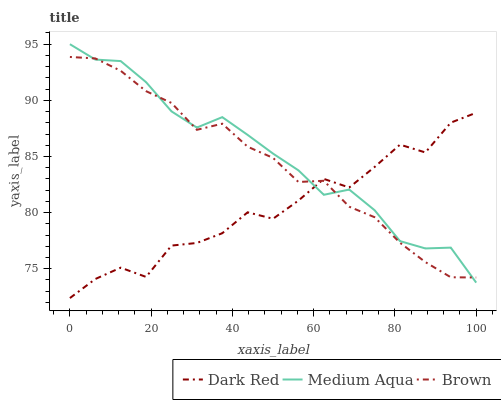Does Dark Red have the minimum area under the curve?
Answer yes or no. Yes. Does Medium Aqua have the maximum area under the curve?
Answer yes or no. Yes. Does Brown have the minimum area under the curve?
Answer yes or no. No. Does Brown have the maximum area under the curve?
Answer yes or no. No. Is Brown the smoothest?
Answer yes or no. Yes. Is Dark Red the roughest?
Answer yes or no. Yes. Is Medium Aqua the smoothest?
Answer yes or no. No. Is Medium Aqua the roughest?
Answer yes or no. No. Does Dark Red have the lowest value?
Answer yes or no. Yes. Does Medium Aqua have the lowest value?
Answer yes or no. No. Does Medium Aqua have the highest value?
Answer yes or no. Yes. Does Brown have the highest value?
Answer yes or no. No. Does Dark Red intersect Brown?
Answer yes or no. Yes. Is Dark Red less than Brown?
Answer yes or no. No. Is Dark Red greater than Brown?
Answer yes or no. No. 